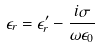<formula> <loc_0><loc_0><loc_500><loc_500>\epsilon _ { r } = \epsilon _ { r } ^ { \prime } - \frac { i \sigma } { \omega \epsilon _ { 0 } }</formula> 